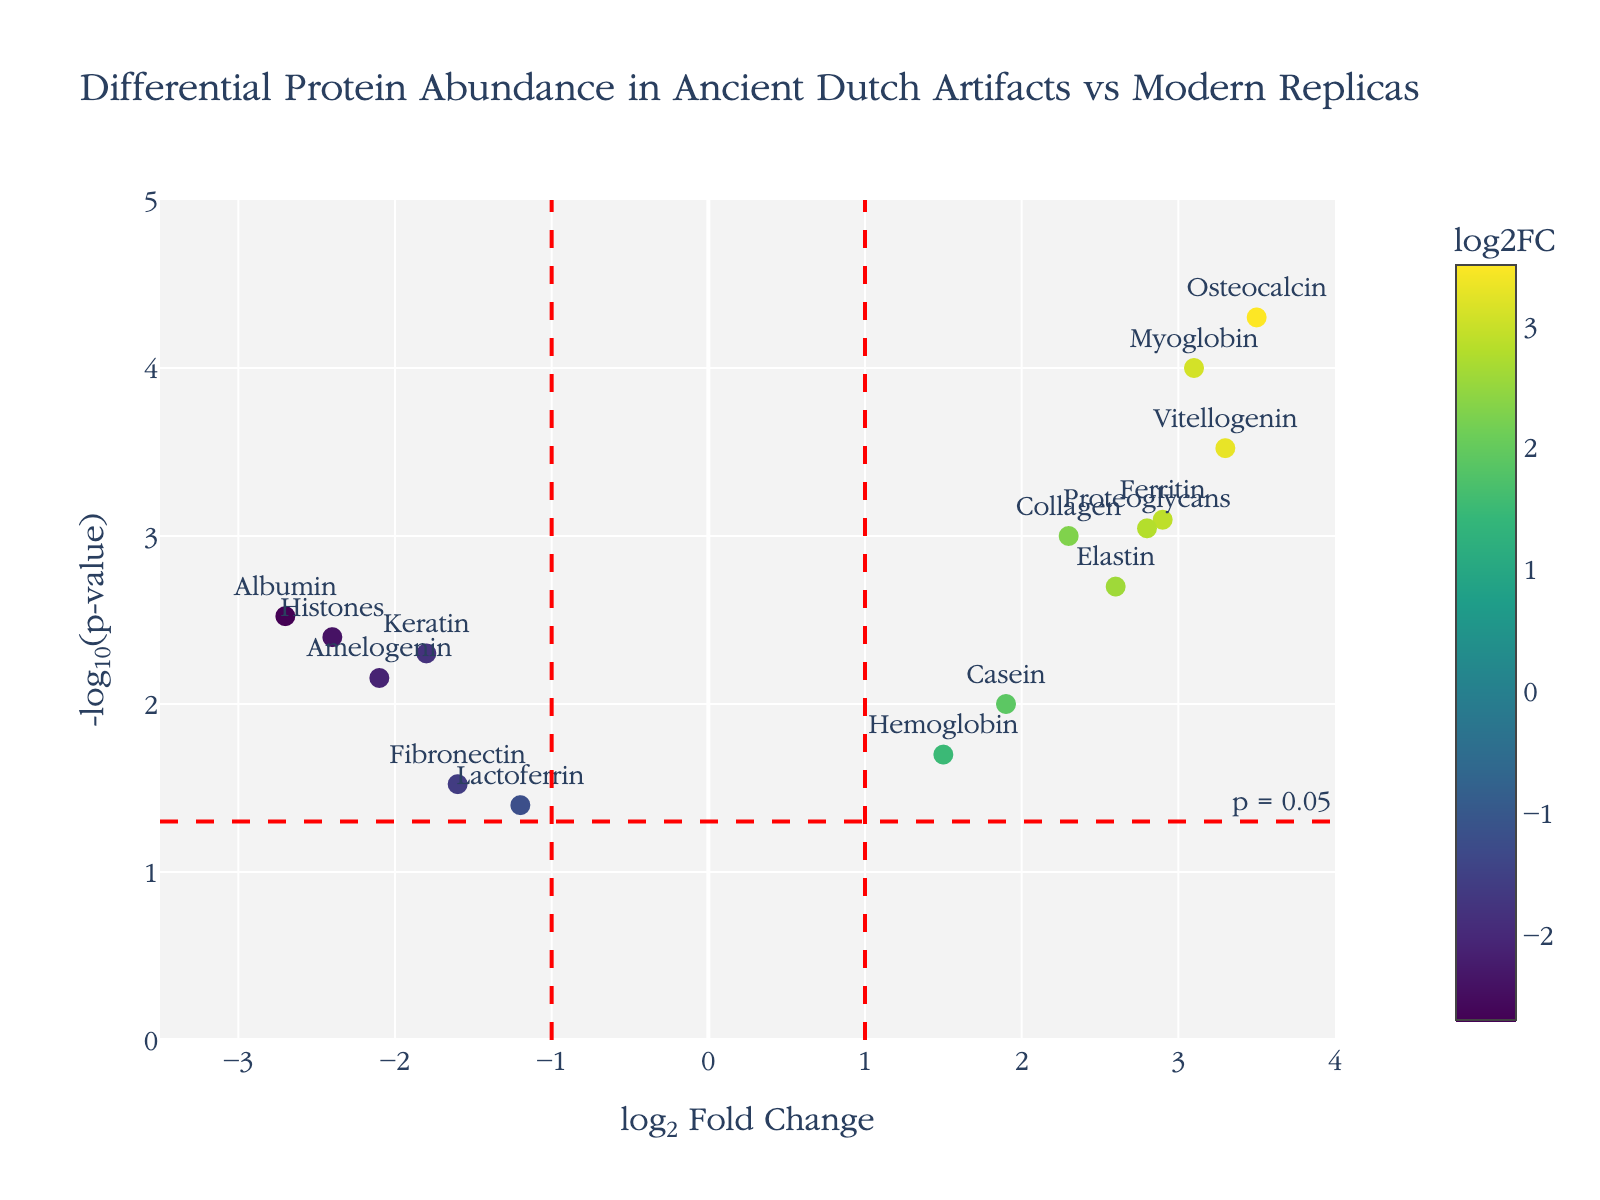what is the main title of the plot? The main title of the plot is located at the top of the figure, usually in a larger and bold font, and it summarizes the essence of the figure.
Answer: Differential Protein Abundance in Ancient Dutch Artifacts vs Modern Replicas how many proteins have a log2FoldChange greater than 1? To find the number of proteins with a log2FoldChange greater than 1, we look at the x-axis values and count the number of markers located to the right of x=1.
Answer: 8 which protein has the highest -log10(p-value)? To identify the protein with the highest -log10(p-value), look for the highest point on the y-axis and check the associated label or hover text.
Answer: Osteocalcin how many proteins have p-values less than 0.05? Count the number of markers that are above the horizontal red dashed line indicating the -log10(0.05) threshold line.
Answer: 14 which proteins show a negative log2FoldChange but have a significant p-value (below 0.05)? First, identify proteins with negative log2FoldChange (left side of x=0). Then, check if their -log10(p-value) positions them above the horizontal red line (indicating p-value < 0.05).
Answer: Keratin, Albumin, Amelogenin, and Histones which proteins have a log2FoldChange between -1 and 1 and are not significant (p-value >= 0.05)? Find proteins with log2FoldChange between -1 and 1 by looking between the vertical dashed lines. Then, check if plot points for these proteins are below the horizontal red line (p-value >= 0.05).
Answer: Lactoferrin and Fibronectin what is the log2FoldChange for the protein with the highest -log10(p-value)? Identify the protein with the highest -log10(p-value), which is the tallest point on the y-axis, and then note its x-axis (log2FoldChange) value.
Answer: 3.5 how many proteins have a -log10(p-value) greater than 3? To determine the number of proteins with -log10(p-value) greater than 3, count the number of points above y=3 on the plot.
Answer: 6 compare the significance of Myoglobin and Hemoglobin in terms of their -log10(p-value). Compare the heights of the points for Myoglobin and Hemoglobin along the y-axis (-log10(p-value)) to determine which is more significant.
Answer: Myoglobin is more significant which protein has the lowest log2FoldChange? Identify the protein with the smallest x-axis value (most leftward point on the plot).
Answer: Albumin 